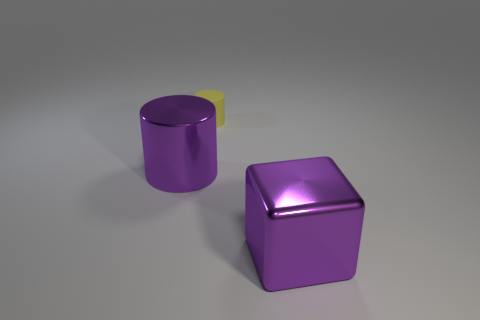Add 3 yellow things. How many objects exist? 6 Subtract all blocks. How many objects are left? 2 Add 3 tiny rubber things. How many tiny rubber things are left? 4 Add 1 small purple cylinders. How many small purple cylinders exist? 1 Subtract 0 green spheres. How many objects are left? 3 Subtract all cubes. Subtract all large purple metal cubes. How many objects are left? 1 